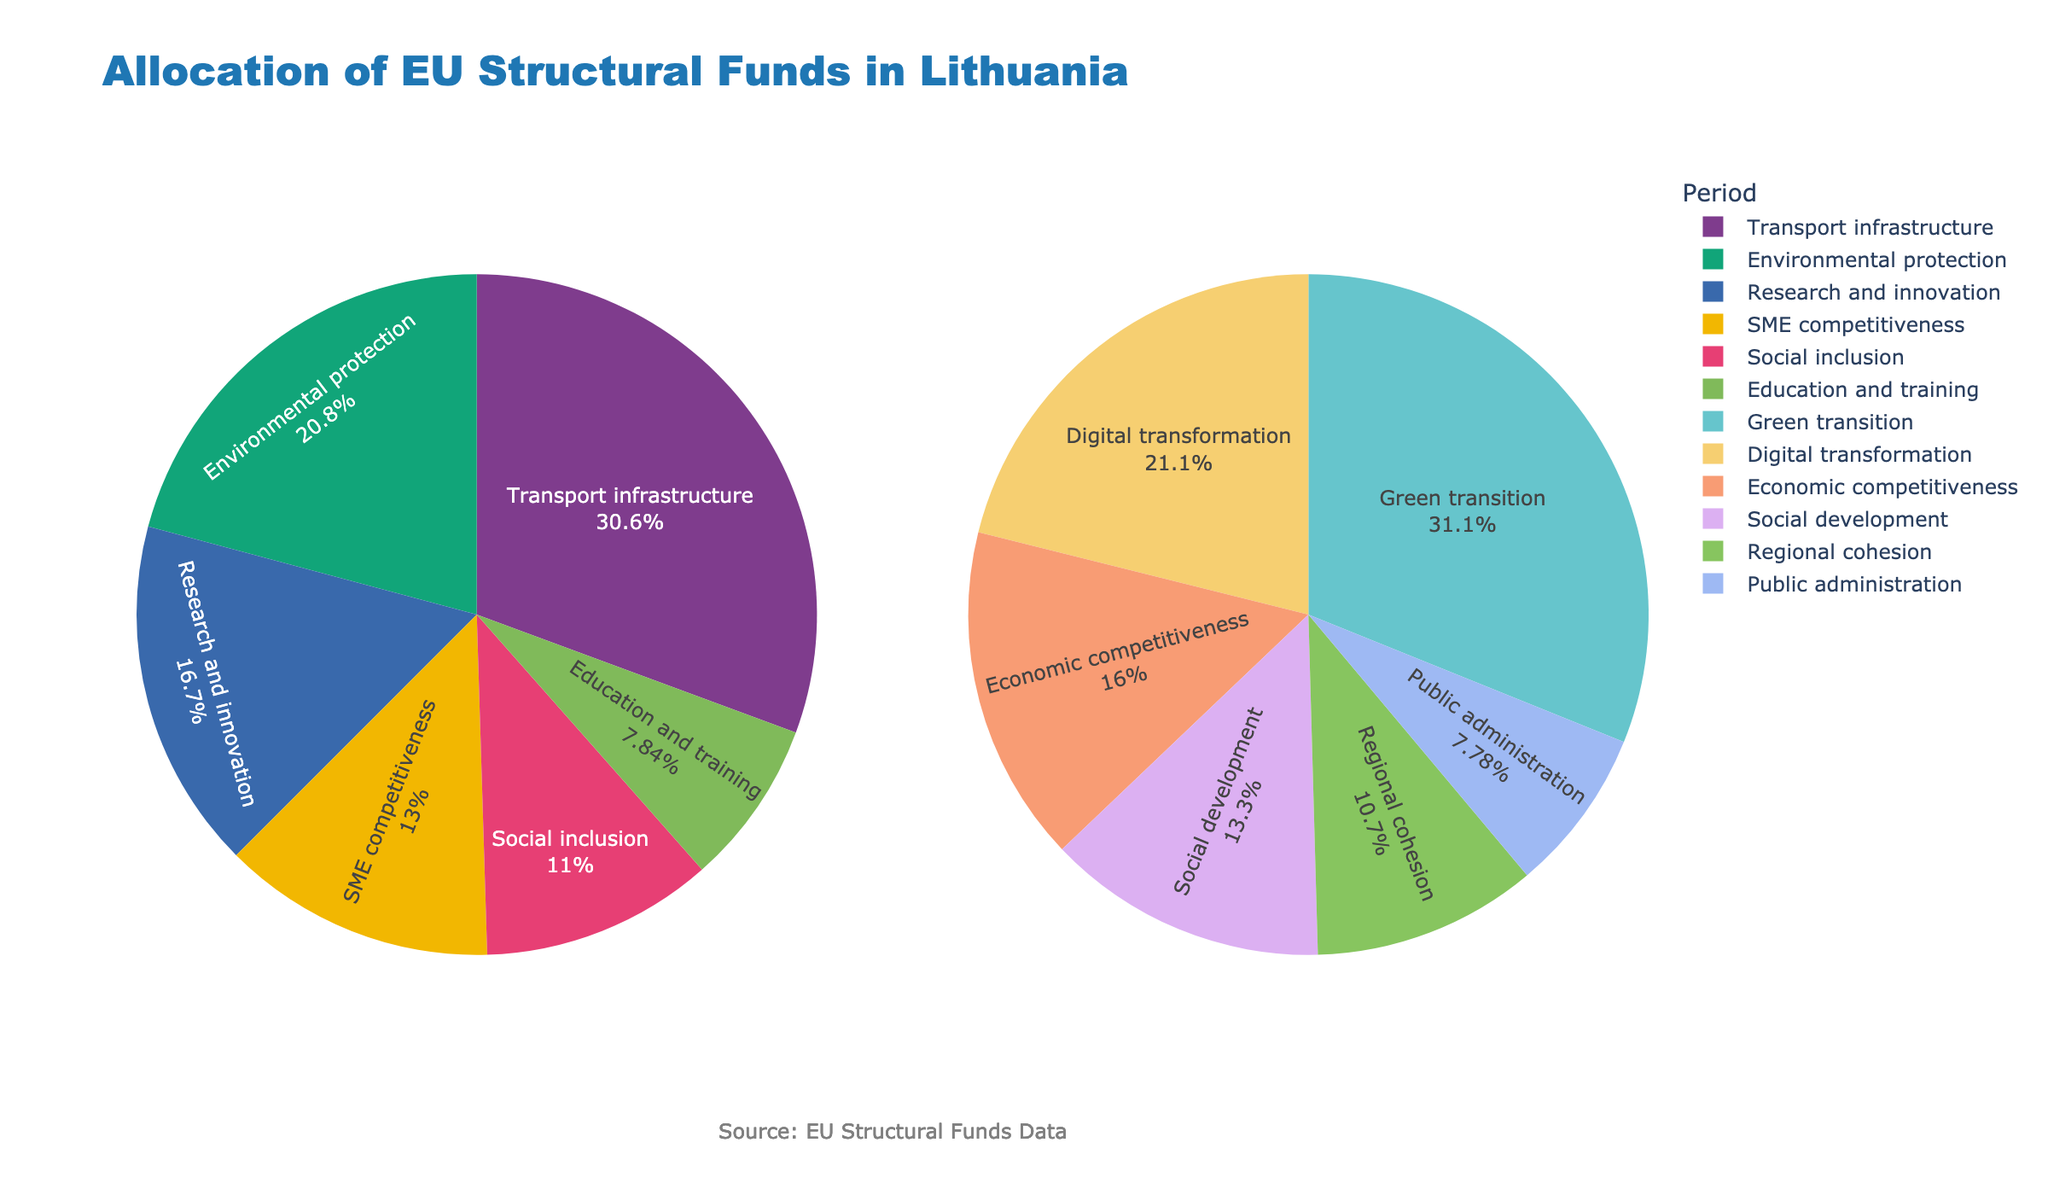What is the main title of the figure? The main title is located at the top of the figure and indicates the subject discussed. The title helps understand the overall content of the figure. In this case, it reads "Allocation of EU Structural Funds in Lithuania".
Answer: Allocation of EU Structural Funds in Lithuania Which category received the most funding in the 2014-2020 period? To find the category with the highest allocation, look for the category that occupies the largest section of the pie chart for 2014-2020. In this figure, the largest section corresponds to "Transport infrastructure".
Answer: Transport infrastructure How much funding was allocated to the "Green transition" category in the 2021-2027 period? By examining the pie chart section for 2021-2027, find the segment labeled "Green transition" and observe its associated funding value. It is labeled with €1400 million.
Answer: €1400 million Which period allocated more funding to "Research and innovation" or its equivalent? First, locate "Research and innovation" in the 2014-2020 pie chart. Then find its equivalent in 2021-2027, in this case, "Economic competitiveness". Compare the allocations: €680 million for 2014-2020 vs. €720 million for 2021-2027.
Answer: 2021-2027 What percentage of the total allocation in the 2021-2027 period was given to "Digital transformation"? Check the 2021-2027 pie chart and find the percentage value indicated for "Digital transformation". The chart shows that "Digital transformation" received 18%.
Answer: 18% What is the difference in the allocation for social-related categories between the two periods? Identify social-related categories: "Social inclusion" (€450 million for 2014-2020) and "Social development" (€600 million for 2021-2027). Subtract the former from the latter: €600 million - €450 million = €150 million.
Answer: €150 million Which category had a higher relative allocation percentage in 2014-2020 than any category in 2021-2027? Compare the percentage labels of each segment in 2014-2020 against those in 2021-2027. "Transport infrastructure" in 2014-2020 has the highest percentage (42%) exceeding any percentage in 2021-2027.
Answer: Transport infrastructure (2014-2020) How do social and environment-related funding allocations compare between the two periods? Look at "Environmental protection" (€850 million for 2014-2020) and "Green transition" (€1400 million for 2021-2027), as well as "Social inclusion" (€450 million for 2014-2020) and "Social development" (€600 million for 2021-2027). Use these to compare trends and absolute values. Environment-related funding increased, and social funding increased as well.
Answer: Both increased What was the percentage of total funds allocated to "Transport infrastructure" in the 2014-2020 period? The percentage value for "Transport infrastructure" is found directly on the 2014-2020 pie chart slice, which indicates 42%.
Answer: 42% Which category experienced the most notable increase in funding from the 2014-2020 to the 2021-2027 period? Compare the allocation values for each category in both periods and look for the largest increase. "Green transition" increased from €0 million to €1400 million, the most notable increase.
Answer: Green transition 